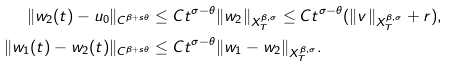Convert formula to latex. <formula><loc_0><loc_0><loc_500><loc_500>\| w _ { 2 } ( t ) - u _ { 0 } \| _ { C ^ { \beta + s \theta } } & \leq C t ^ { \sigma - \theta } \| w _ { 2 } \| _ { X ^ { \beta , \sigma } _ { T } } \leq C t ^ { \sigma - \theta } ( \| v \| _ { X ^ { \beta , \sigma } _ { T } } + r ) , \\ \| w _ { 1 } ( t ) - w _ { 2 } ( t ) \| _ { C ^ { \beta + s \theta } } & \leq C t ^ { \sigma - \theta } \| w _ { 1 } - w _ { 2 } \| _ { X ^ { \beta , \sigma } _ { T } } .</formula> 